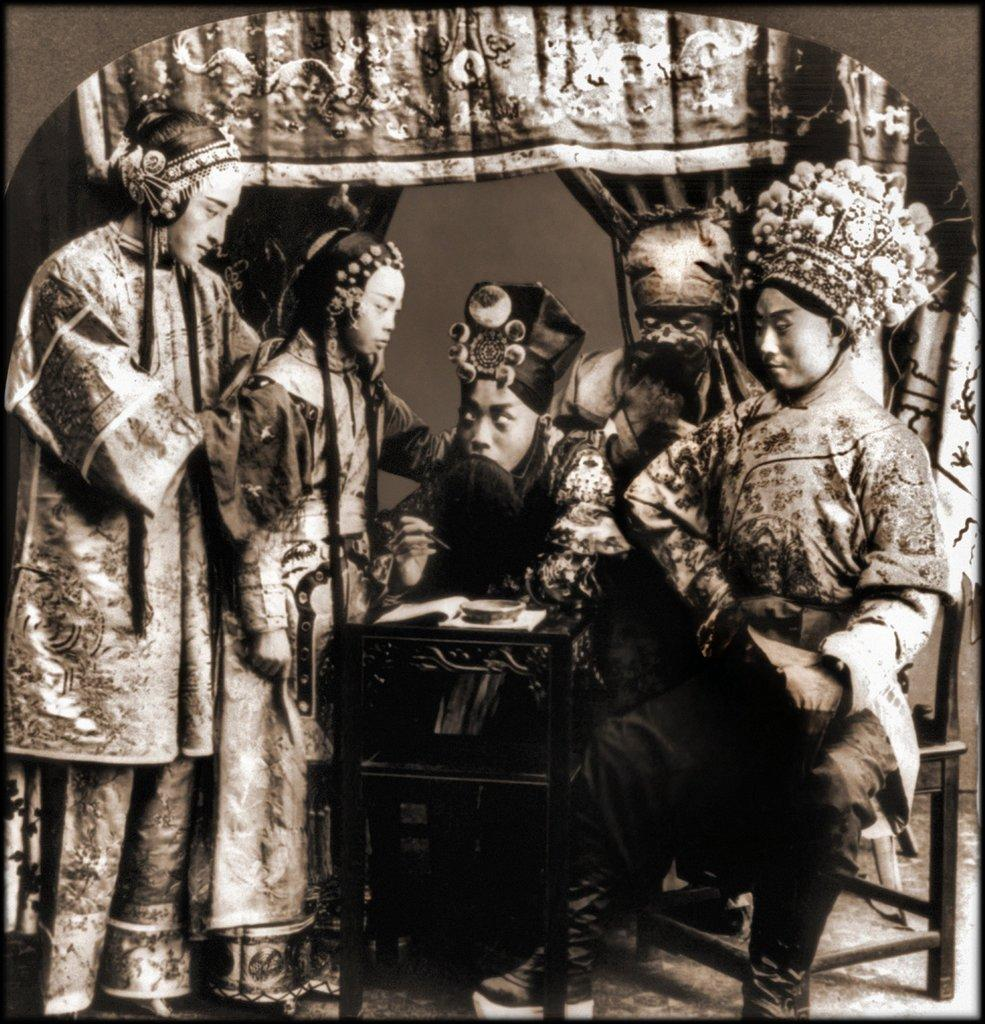What is the color scheme of the image? The image is black and white. What can be seen in the image? There are people in the image. What are the people wearing? The people are wearing clothes. What are the people doing in the image? Some people are sitting, while others are standing. What furniture is present in the image? There is a chair and a table in the image. What type of grain is being harvested in the image? There is no grain or harvesting activity present in the image; it features people in a black and white setting. 